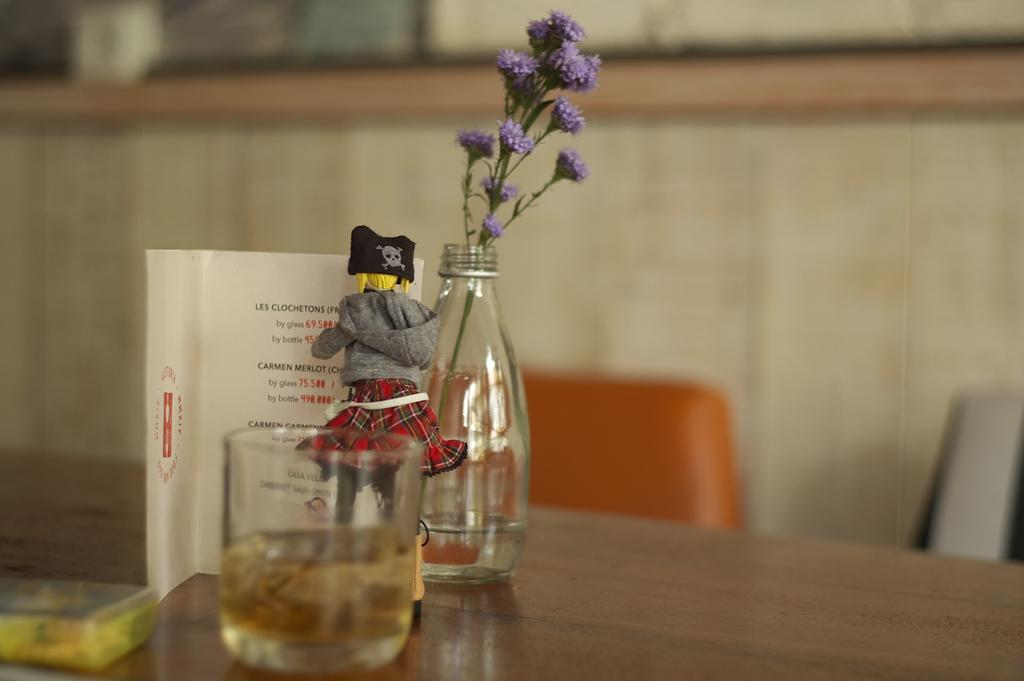What is in the glass that is visible in the image? There is a glass of drink in the image. What is unique about the flower vase in the image? The flower vase is in a bottle in the image. What type of toy is present in the image? There is a doll in the image. What type of object is used for reading in the image? There is a book in the image. What is on the table in the image? There is a box on the table in the image. What color is the chair in the image? There is a chair in orange color in the image. What song is being played by the geese in the image? There are no geese present in the image, so no song can be heard. What is the edge of the glass used for in the image? The edge of the glass is not used for anything in the image; it is simply the rim of the glass. 